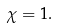Convert formula to latex. <formula><loc_0><loc_0><loc_500><loc_500>\chi = 1 .</formula> 